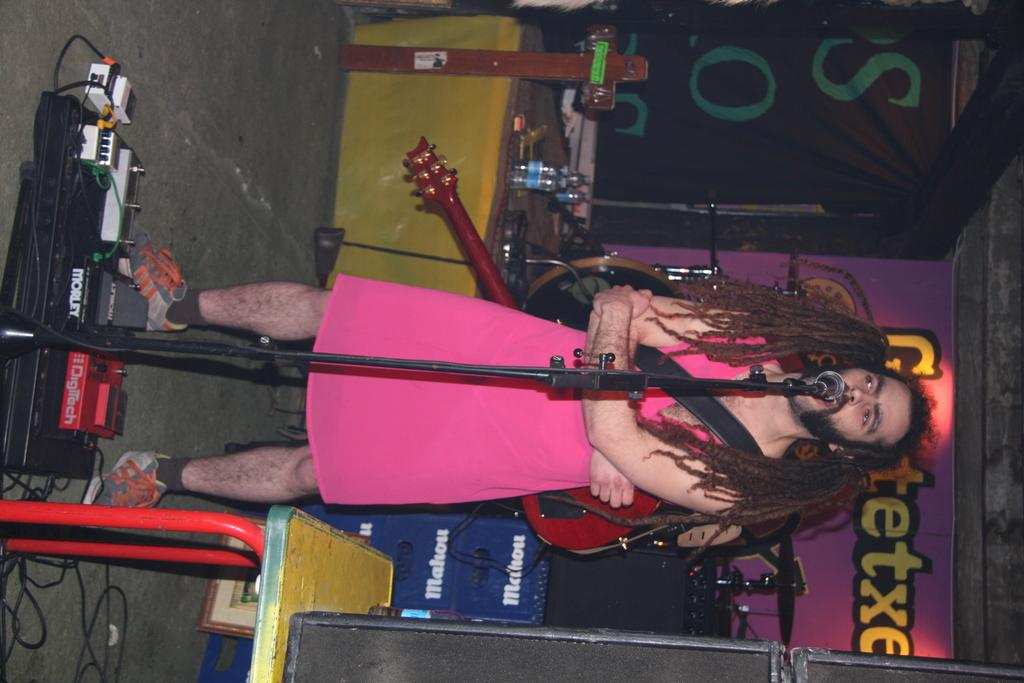What is the main subject of the image? There is a person in the image. What is the person doing in the image? The person is standing. What is the person wearing in the image? The person is wearing a guitar. What other objects can be seen in the image? There is a microphone and a stand in the image. What type of disease is the person suffering from in the image? There is no indication of any disease in the image; the person is simply standing and wearing a guitar. 